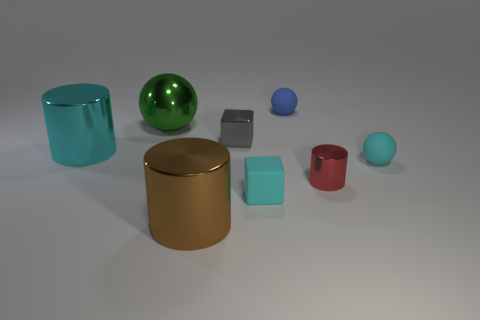Subtract all small rubber spheres. How many spheres are left? 1 Add 2 big cyan cubes. How many objects exist? 10 Subtract all gray blocks. How many blocks are left? 1 Subtract 1 balls. How many balls are left? 2 Subtract 0 purple blocks. How many objects are left? 8 Subtract all cylinders. How many objects are left? 5 Subtract all cyan cylinders. Subtract all green cubes. How many cylinders are left? 2 Subtract all brown spheres. How many yellow cylinders are left? 0 Subtract all brown metal things. Subtract all big metallic spheres. How many objects are left? 6 Add 4 cyan shiny things. How many cyan shiny things are left? 5 